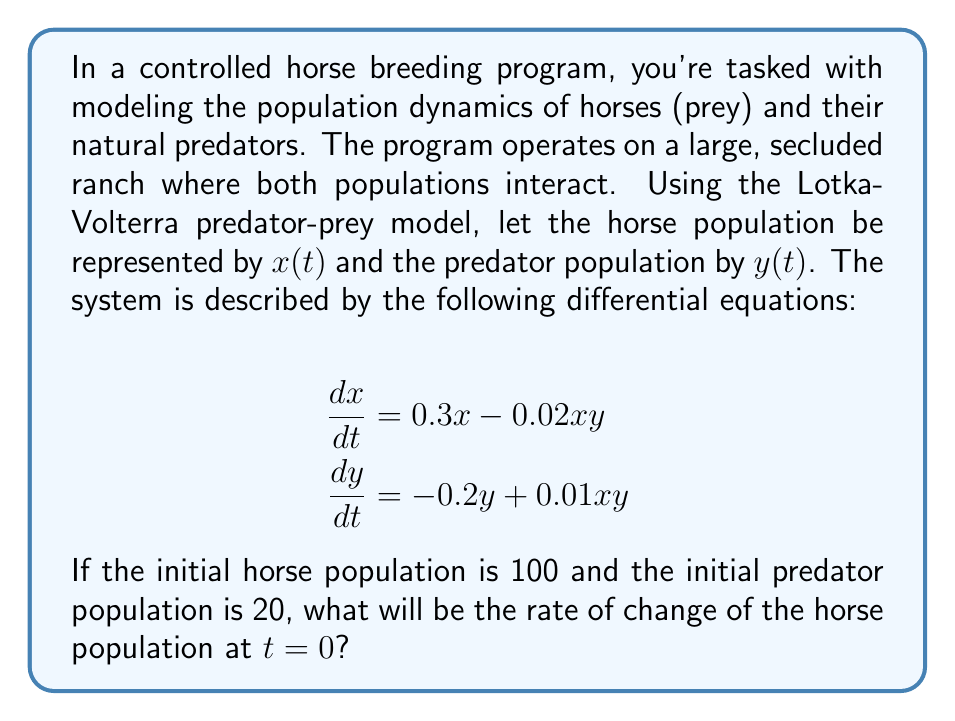Help me with this question. To solve this problem, we need to use the given Lotka-Volterra equations and the initial conditions. Let's break it down step-by-step:

1) We are given two differential equations:
   $$\frac{dx}{dt} = 0.3x - 0.02xy$$
   $$\frac{dy}{dt} = -0.2y + 0.01xy$$

2) We're asked to find the rate of change of the horse population ($\frac{dx}{dt}$) at $t=0$.

3) We're given initial conditions:
   $x(0) = 100$ (initial horse population)
   $y(0) = 20$ (initial predator population)

4) To find $\frac{dx}{dt}$ at $t=0$, we need to substitute these initial values into the first equation:

   $$\frac{dx}{dt} = 0.3x - 0.02xy$$

5) Substituting $x=100$ and $y=20$:

   $$\frac{dx}{dt} = 0.3(100) - 0.02(100)(20)$$

6) Now let's calculate:
   $$\frac{dx}{dt} = 30 - 40 = -10$$

Therefore, at $t=0$, the rate of change of the horse population is -10 horses per unit time.
Answer: $-10$ horses per unit time 